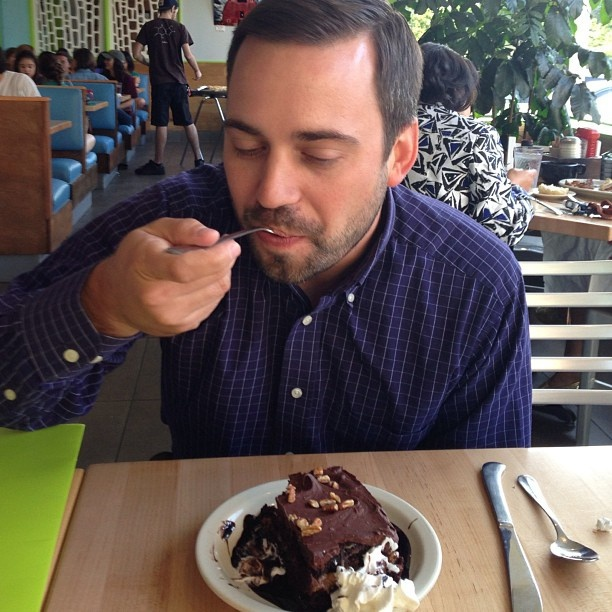Describe the objects in this image and their specific colors. I can see people in teal, black, navy, brown, and gray tones, bowl in teal, black, darkgray, maroon, and gray tones, people in teal, gray, lightgray, black, and darkgray tones, chair in teal, black, ivory, gray, and darkgray tones, and people in teal, black, gray, and darkgray tones in this image. 